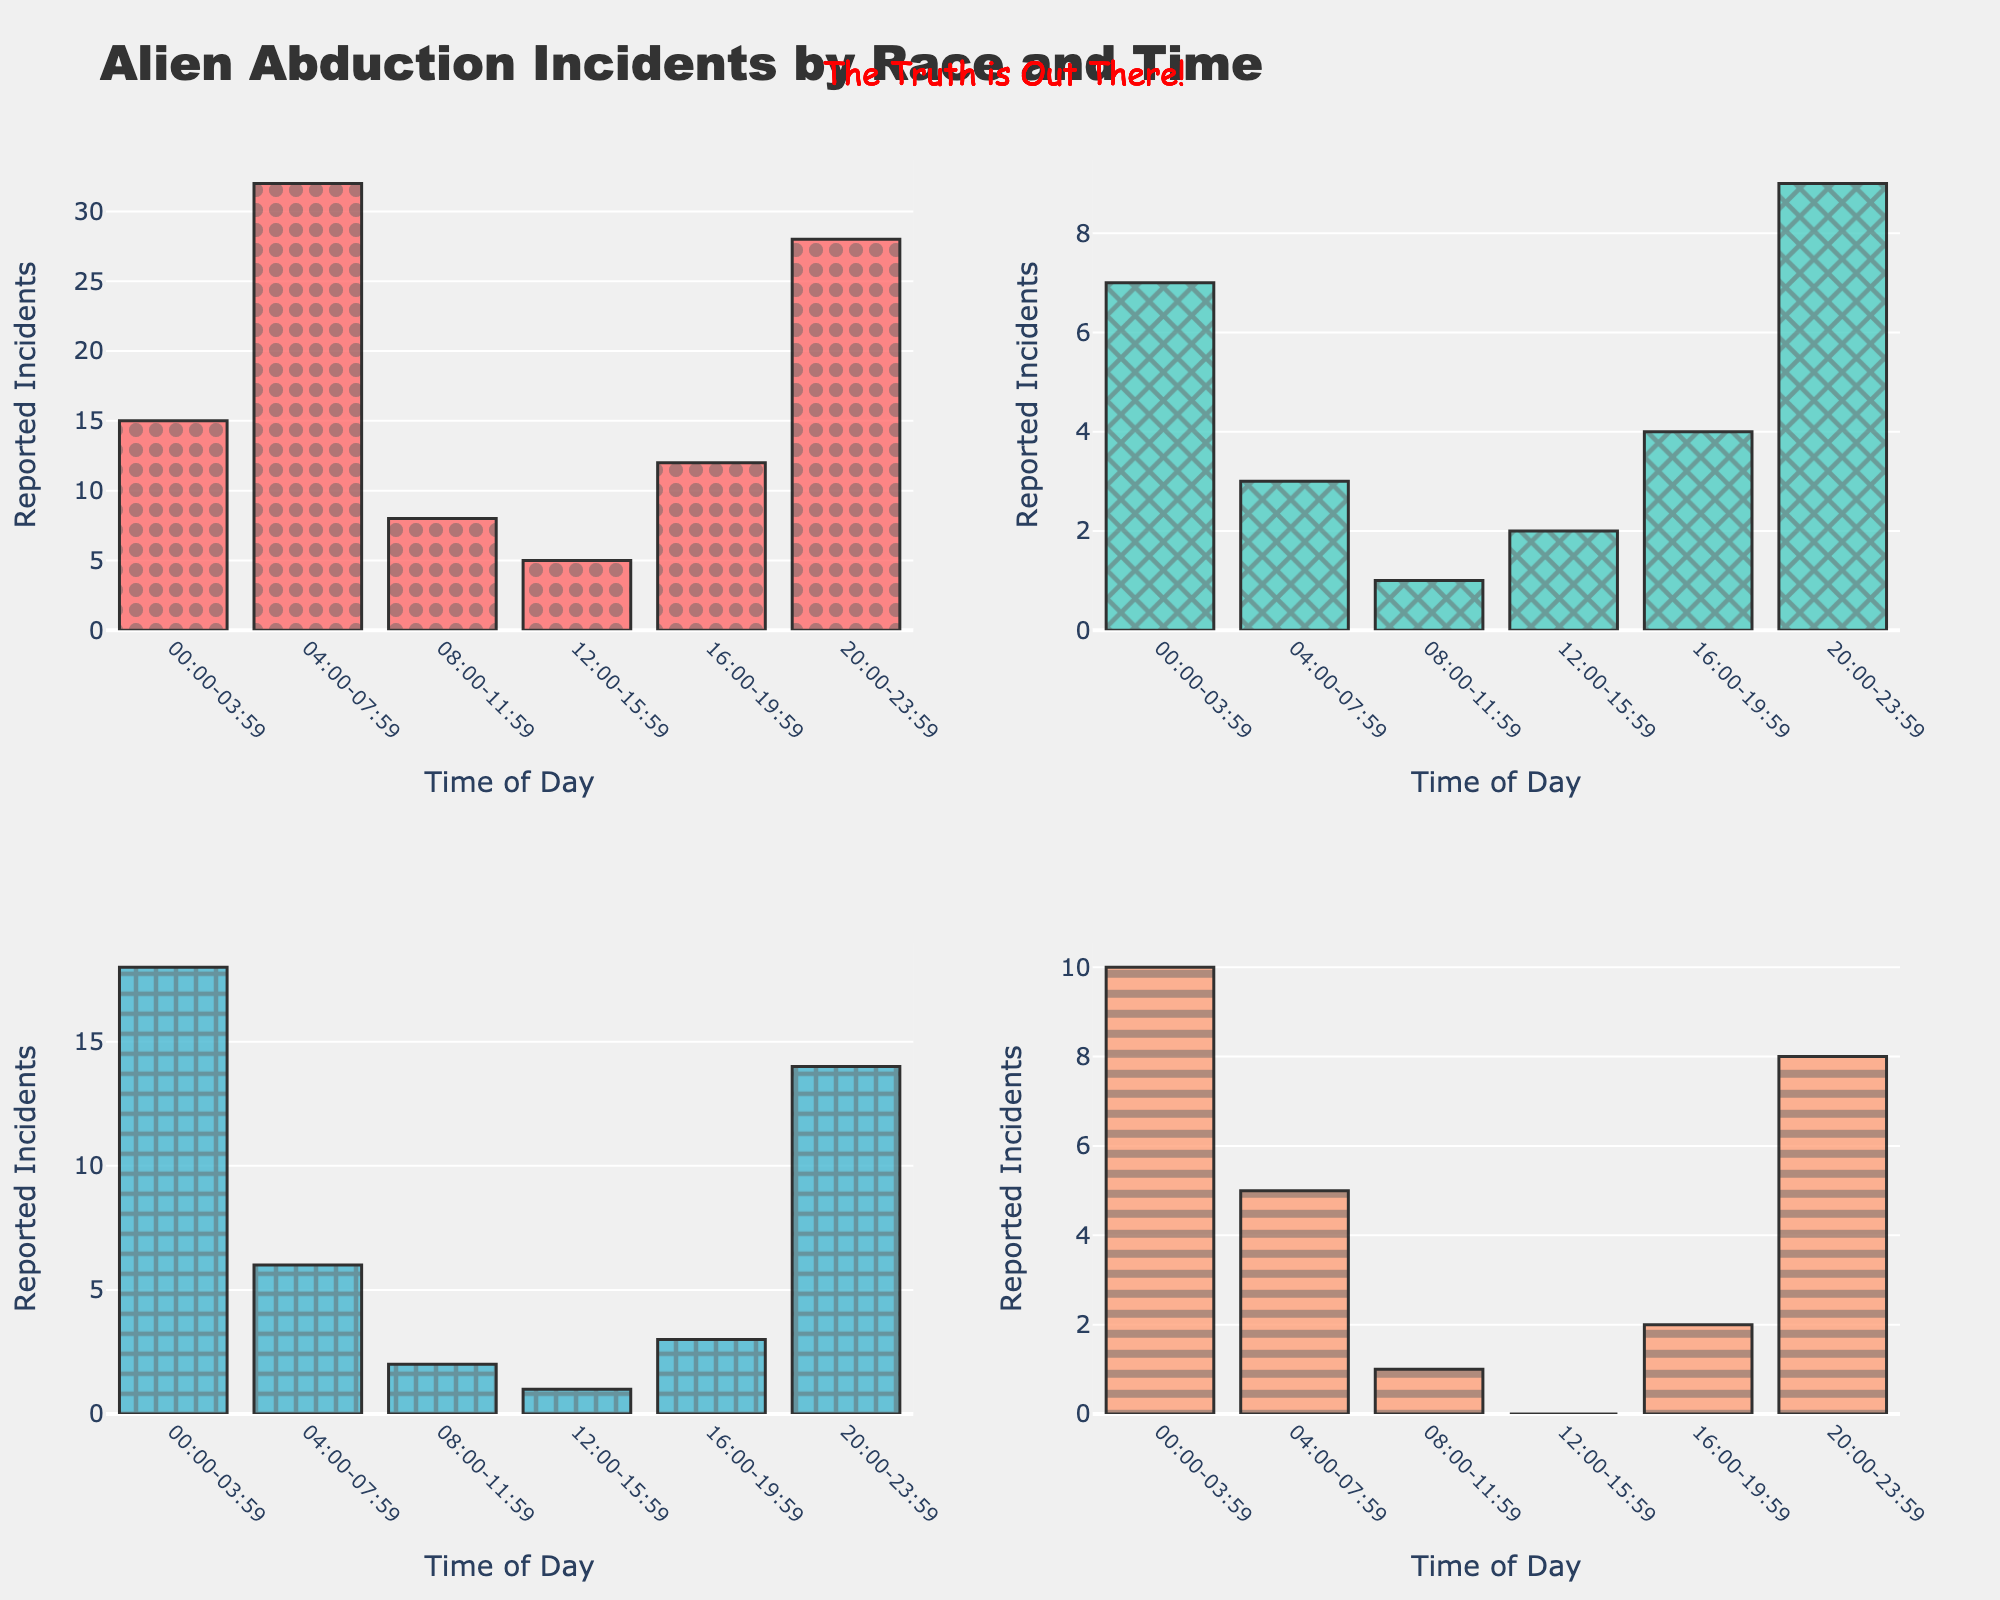Which alien race has the highest number of reported incidents between 4:00-7:59? To find out which alien race has the highest number of incidents between 4:00-7:59, look at the values for each race in this time slot. The Grey race has 32 reported incidents, the Nordic race has 3, the Reptilian race has 6, and the Mantis race has 5.
Answer: Grey How many total incidents are reported for the Grey race throughout the entire day? Add up the reported incidents for the Grey race across all time slots: 15 (00:00-03:59) + 32 (04:00-07:59) + 8 (08:00-11:59) + 5 (12:00-15:59) + 12 (16:00-19:59) + 28 (20:00-23:59) = 100.
Answer: 100 Which time slot has the highest number of incidents for the Reptilian race? Inspecting the data for the Reptilian race, we see: 18 (00:00-03:59), 6 (04:00-07:59), 2 (08:00-11:59), 1 (12:00-15:59), 3 (16:00-19:59), and 14 (20:00-23:59). The highest value is in the 00:00-03:59 slot with 18 incidents.
Answer: 00:00-03:59 Compare the total number of incidents between the Nordic and Mantis races. Which one has more reported incidents? Summing the incidents for each race: Nordic (7 + 3 + 1 + 2 + 4 + 9 = 26) and Mantis (10 + 5 + 1 + 0 + 2 + 8 = 26). Both races have the same number of reported incidents.
Answer: Equal During which time slot do alien abduction incidents peak for the Grey race? Reviewing the incident counts for the Grey race by time slot: 00:00-03:59 (15), 04:00-07:59 (32), 08:00-11:59 (8), 12:00-15:59 (5), 16:00-19:59 (12), 20:00-23:59 (28), the peak occurs in the 04:00-07:59 slot with 32 incidents.
Answer: 04:00-07:59 Which alien race has the lowest number of incidents in the 20:00-23:59 time slot? Check the counts for each race in the 20:00-23:59 time slot: Grey (28), Nordic (9), Reptilian (14), and Mantis (8). The Nordic race has the lowest number of incidents with 9.
Answer: Nordic What is the combined total of reported incidents for the 08:00-11:59 time slot across all races? Sum the incidents for all races in the 08:00-11:59 time slot: Grey (8) + Nordic (1) + Reptilian (2) + Mantis (1) = 12.
Answer: 12 What is the average number of reported incidents for the Mantis race across all time slots? To find the average, sum the incidents for the Mantis race and divide by the number of time slots: (10 + 5 + 1 + 0 + 2 + 8) / 6 = 26 / 6 ≈ 4.33.
Answer: 4.33 If the number of incidents for each race in the 16:00-19:59 time slot increased by 5, which race would then have the most incidents in that slot? Adding 5 to each race's incidents in the 16:00-19:59 slot: Grey (12 + 5 = 17), Nordic (4 + 5 = 9), Reptilian (3 + 5 = 8), and Mantis (2 + 5 = 7). The Grey race would have the most incidents with 17.
Answer: Grey 